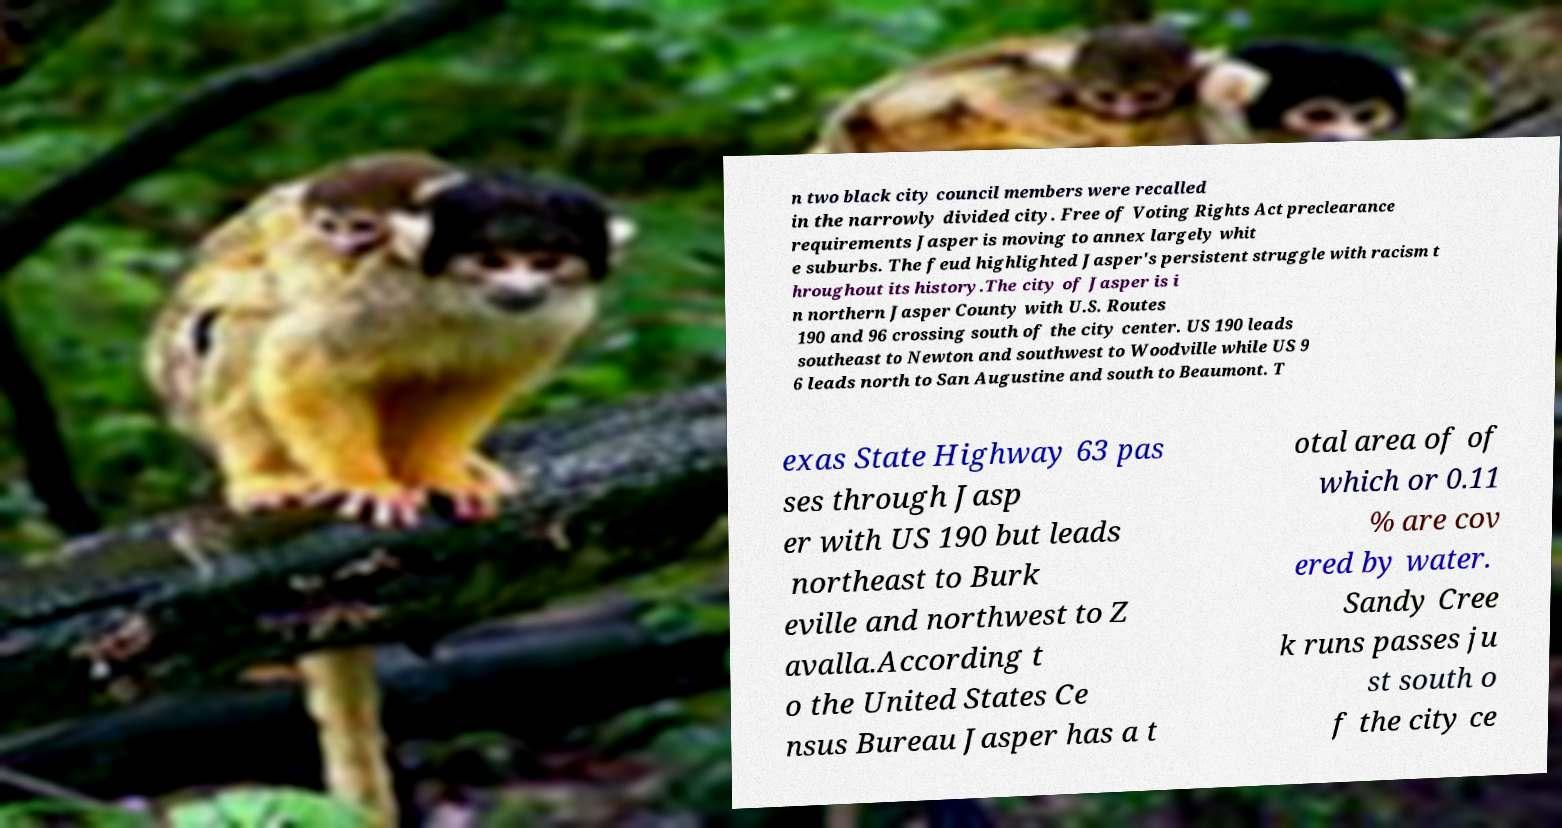Can you accurately transcribe the text from the provided image for me? n two black city council members were recalled in the narrowly divided city. Free of Voting Rights Act preclearance requirements Jasper is moving to annex largely whit e suburbs. The feud highlighted Jasper's persistent struggle with racism t hroughout its history.The city of Jasper is i n northern Jasper County with U.S. Routes 190 and 96 crossing south of the city center. US 190 leads southeast to Newton and southwest to Woodville while US 9 6 leads north to San Augustine and south to Beaumont. T exas State Highway 63 pas ses through Jasp er with US 190 but leads northeast to Burk eville and northwest to Z avalla.According t o the United States Ce nsus Bureau Jasper has a t otal area of of which or 0.11 % are cov ered by water. Sandy Cree k runs passes ju st south o f the city ce 